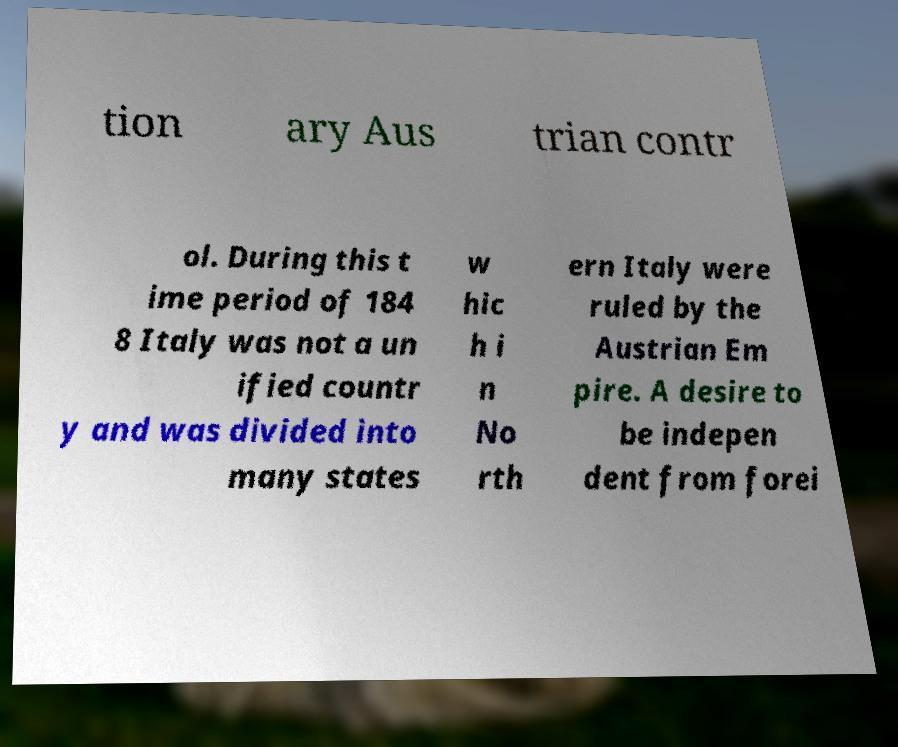Can you accurately transcribe the text from the provided image for me? tion ary Aus trian contr ol. During this t ime period of 184 8 Italy was not a un ified countr y and was divided into many states w hic h i n No rth ern Italy were ruled by the Austrian Em pire. A desire to be indepen dent from forei 